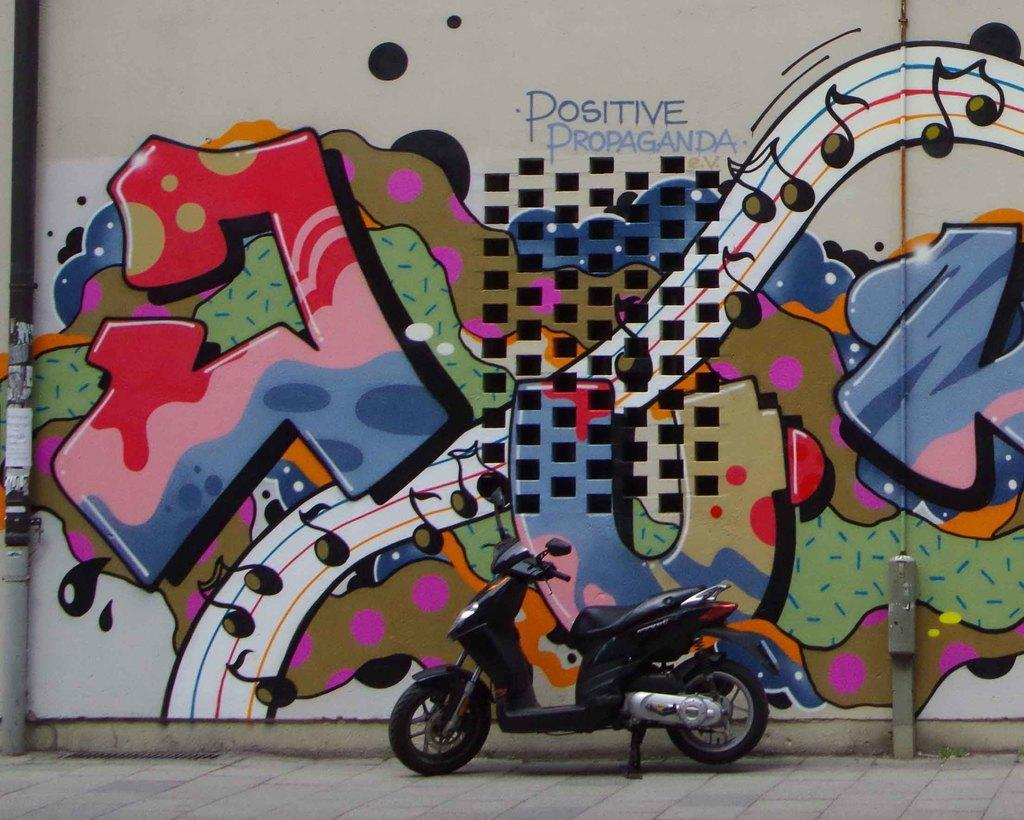What can be seen on the road in the image? There is a bike on the road in the image. What is located beside the road in the image? There is a wall beside the road in the image. What is depicted on the wall in the image? There is a painting on the wall in the image. What does the writer regret in the image? There is no writer or any indication of regret in the image. The image only features a bike on the road, a wall, and a painting on the wall. 